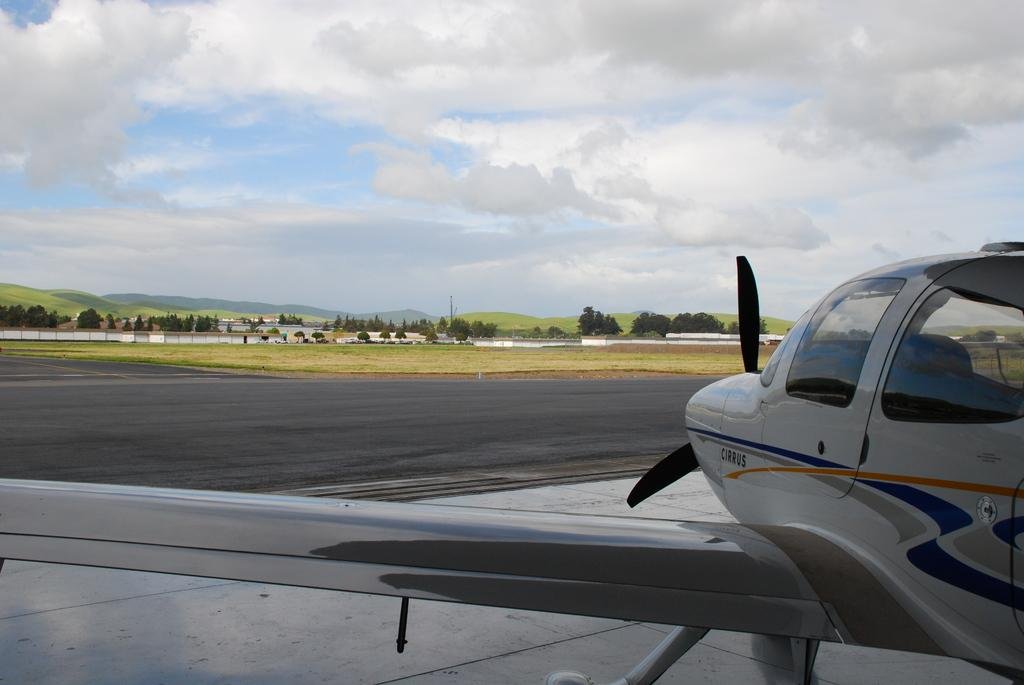What is the main subject of the picture? The main subject of the picture is a plane. What can be seen in the background of the picture? There is grass, trees, and clouds visible in the background of the picture. What type of lamp is hanging from the tree in the picture? There is no lamp present in the picture; it features a plane and a background with grass, trees, and clouds. 